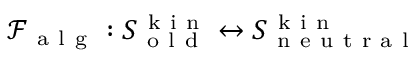Convert formula to latex. <formula><loc_0><loc_0><loc_500><loc_500>\mathcal { F } _ { a l g } \colon S _ { o l d } ^ { k i n } \leftrightarrow S _ { n e u t r a l } ^ { k i n }</formula> 